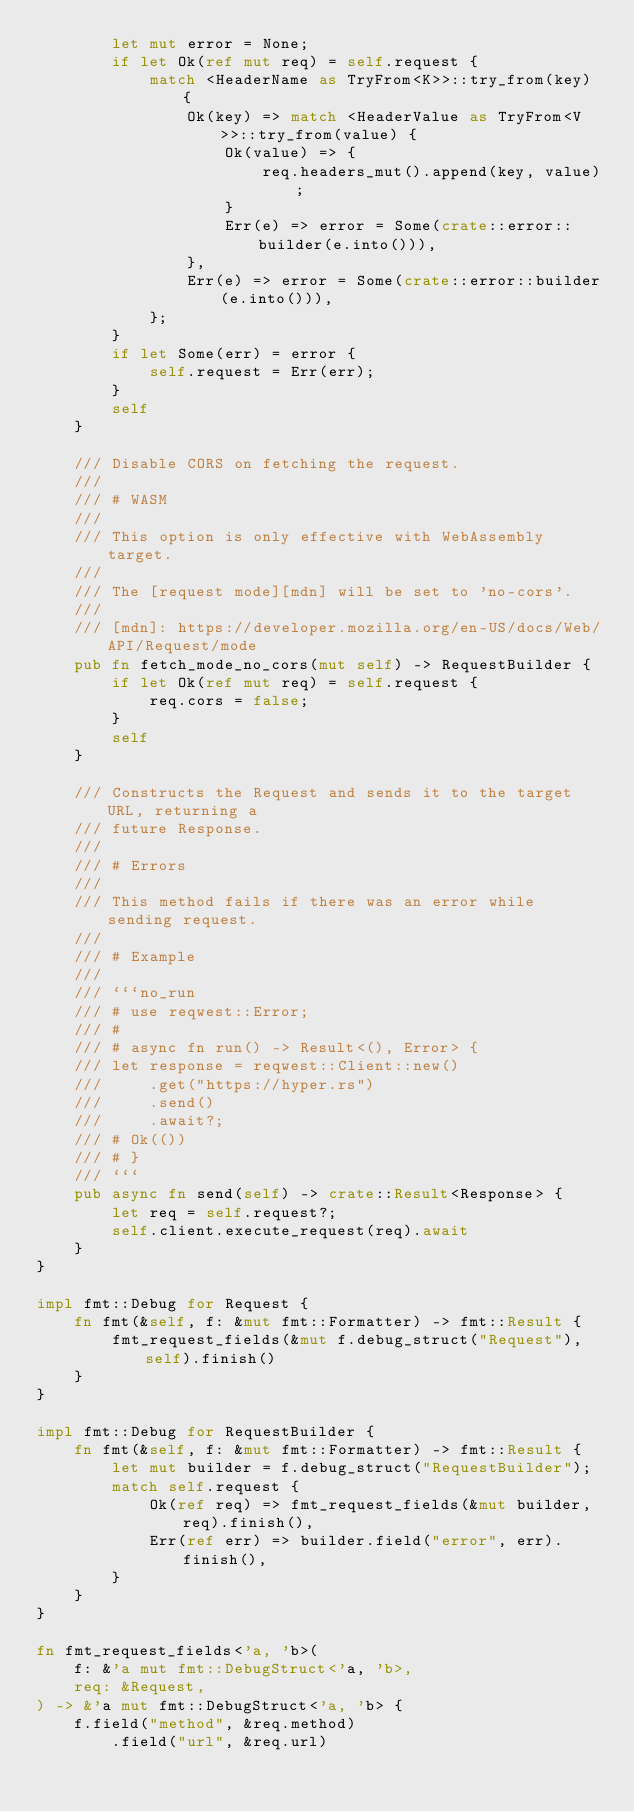Convert code to text. <code><loc_0><loc_0><loc_500><loc_500><_Rust_>        let mut error = None;
        if let Ok(ref mut req) = self.request {
            match <HeaderName as TryFrom<K>>::try_from(key) {
                Ok(key) => match <HeaderValue as TryFrom<V>>::try_from(value) {
                    Ok(value) => {
                        req.headers_mut().append(key, value);
                    }
                    Err(e) => error = Some(crate::error::builder(e.into())),
                },
                Err(e) => error = Some(crate::error::builder(e.into())),
            };
        }
        if let Some(err) = error {
            self.request = Err(err);
        }
        self
    }

    /// Disable CORS on fetching the request.
    ///
    /// # WASM
    ///
    /// This option is only effective with WebAssembly target.
    ///
    /// The [request mode][mdn] will be set to 'no-cors'.
    ///
    /// [mdn]: https://developer.mozilla.org/en-US/docs/Web/API/Request/mode
    pub fn fetch_mode_no_cors(mut self) -> RequestBuilder {
        if let Ok(ref mut req) = self.request {
            req.cors = false;
        }
        self
    }

    /// Constructs the Request and sends it to the target URL, returning a
    /// future Response.
    ///
    /// # Errors
    ///
    /// This method fails if there was an error while sending request.
    ///
    /// # Example
    ///
    /// ```no_run
    /// # use reqwest::Error;
    /// #
    /// # async fn run() -> Result<(), Error> {
    /// let response = reqwest::Client::new()
    ///     .get("https://hyper.rs")
    ///     .send()
    ///     .await?;
    /// # Ok(())
    /// # }
    /// ```
    pub async fn send(self) -> crate::Result<Response> {
        let req = self.request?;
        self.client.execute_request(req).await
    }
}

impl fmt::Debug for Request {
    fn fmt(&self, f: &mut fmt::Formatter) -> fmt::Result {
        fmt_request_fields(&mut f.debug_struct("Request"), self).finish()
    }
}

impl fmt::Debug for RequestBuilder {
    fn fmt(&self, f: &mut fmt::Formatter) -> fmt::Result {
        let mut builder = f.debug_struct("RequestBuilder");
        match self.request {
            Ok(ref req) => fmt_request_fields(&mut builder, req).finish(),
            Err(ref err) => builder.field("error", err).finish(),
        }
    }
}

fn fmt_request_fields<'a, 'b>(
    f: &'a mut fmt::DebugStruct<'a, 'b>,
    req: &Request,
) -> &'a mut fmt::DebugStruct<'a, 'b> {
    f.field("method", &req.method)
        .field("url", &req.url)</code> 